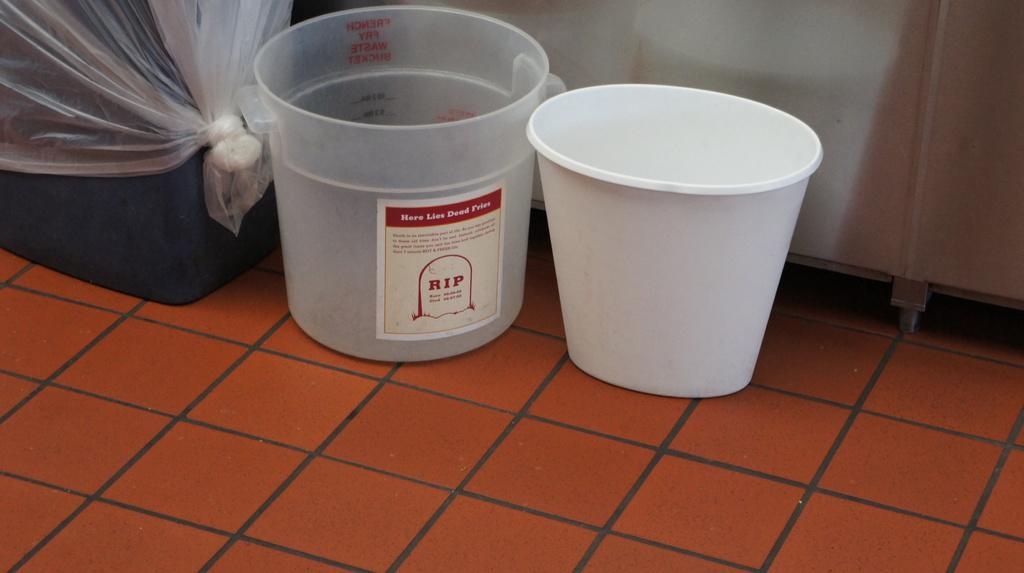<image>
Summarize the visual content of the image. A plastic bucket that has RIP on the label 